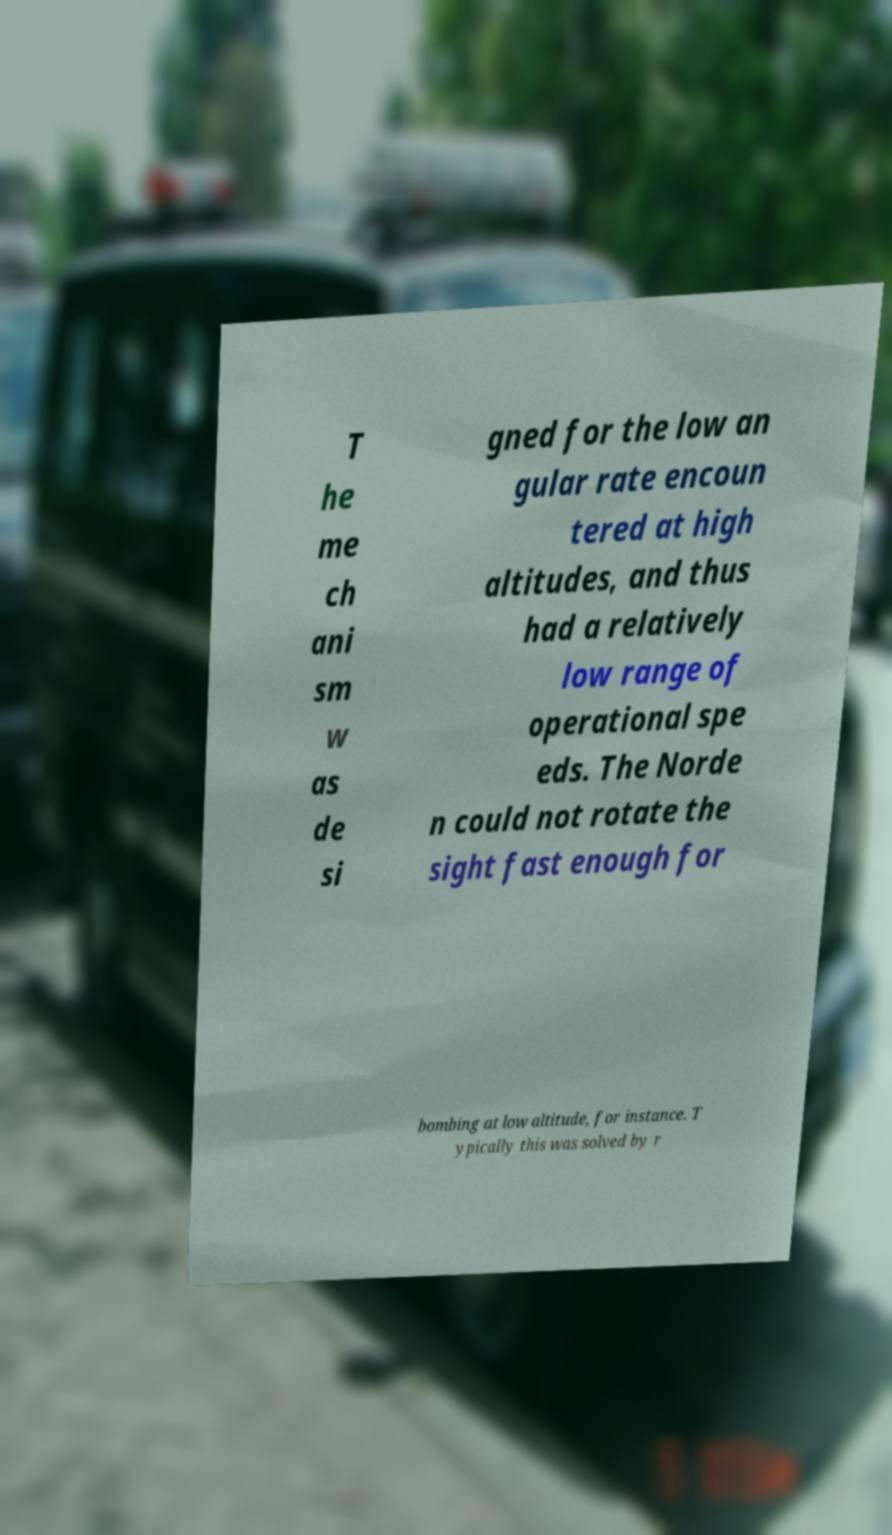For documentation purposes, I need the text within this image transcribed. Could you provide that? T he me ch ani sm w as de si gned for the low an gular rate encoun tered at high altitudes, and thus had a relatively low range of operational spe eds. The Norde n could not rotate the sight fast enough for bombing at low altitude, for instance. T ypically this was solved by r 